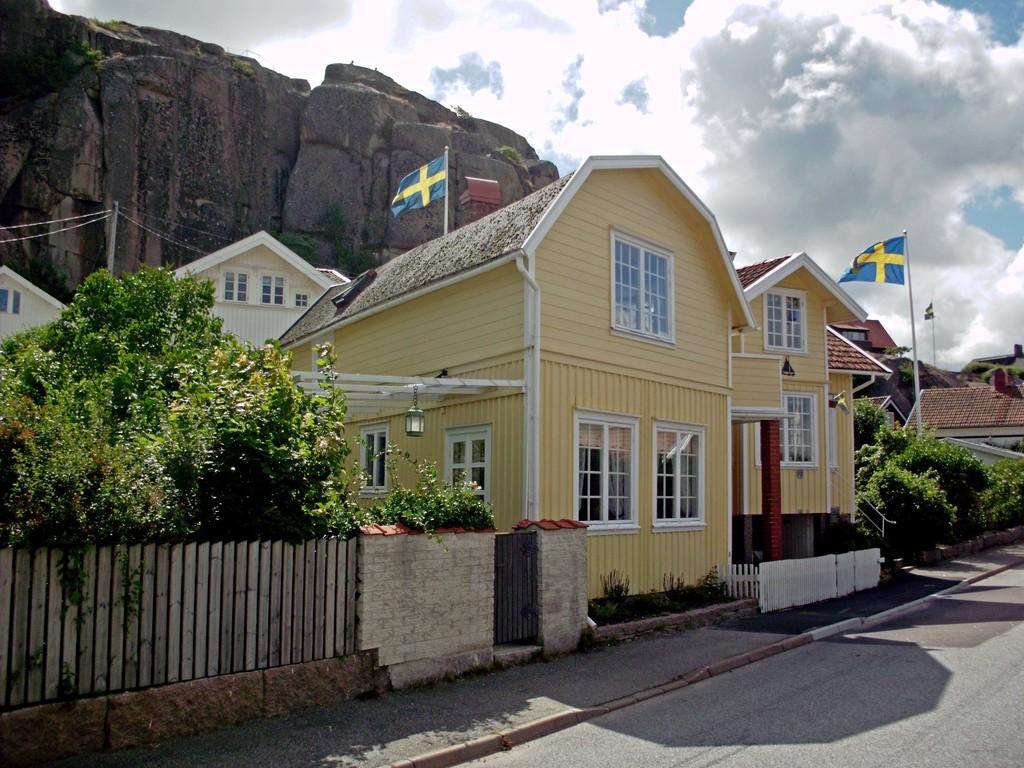How would you summarize this image in a sentence or two? In this picture I can see there is a road, a walk way, there is a building at left and it has a door, window and there are few trees, plants and there are few flagpoles and flags. There is a huge rock at left and the sky is clear. 